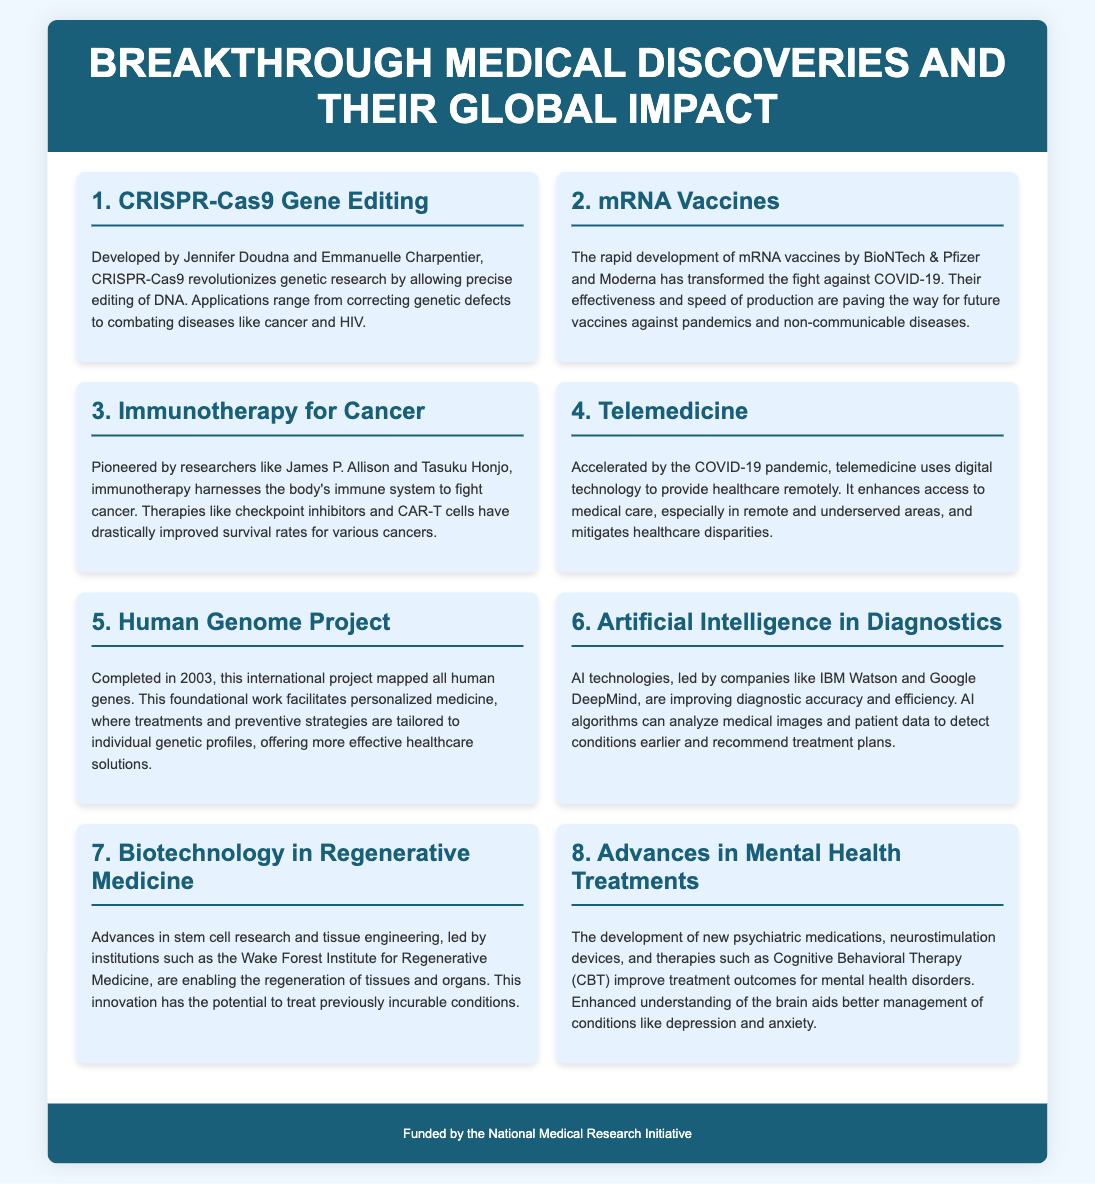What is the first breakthrough listed? The first breakthrough listed in the infographic is CRISPR-Cas9 Gene Editing.
Answer: CRISPR-Cas9 Gene Editing Who developed mRNA vaccines? mRNA vaccines were rapidly developed by BioNTech & Pfizer and Moderna.
Answer: BioNTech & Pfizer and Moderna What year was the Human Genome Project completed? The Human Genome Project was completed in 2003.
Answer: 2003 Which medical advance improves access to healthcare remotely? Telemedicine enhances access to healthcare remotely.
Answer: Telemedicine What is the focus of advances in mental health treatments? Advances in mental health treatments focus on improving treatment outcomes for mental health disorders.
Answer: Improving treatment outcomes How many items are listed on the infographic? There are eight breakthrough medical discoveries listed in the infographic.
Answer: Eight What two researchers pioneered immunotherapy for cancer? The researchers James P. Allison and Tasuku Honjo pioneered immunotherapy for cancer.
Answer: James P. Allison and Tasuku Honjo Which technology is improving diagnostic accuracy? Artificial Intelligence technologies are improving diagnostic accuracy.
Answer: Artificial Intelligence 